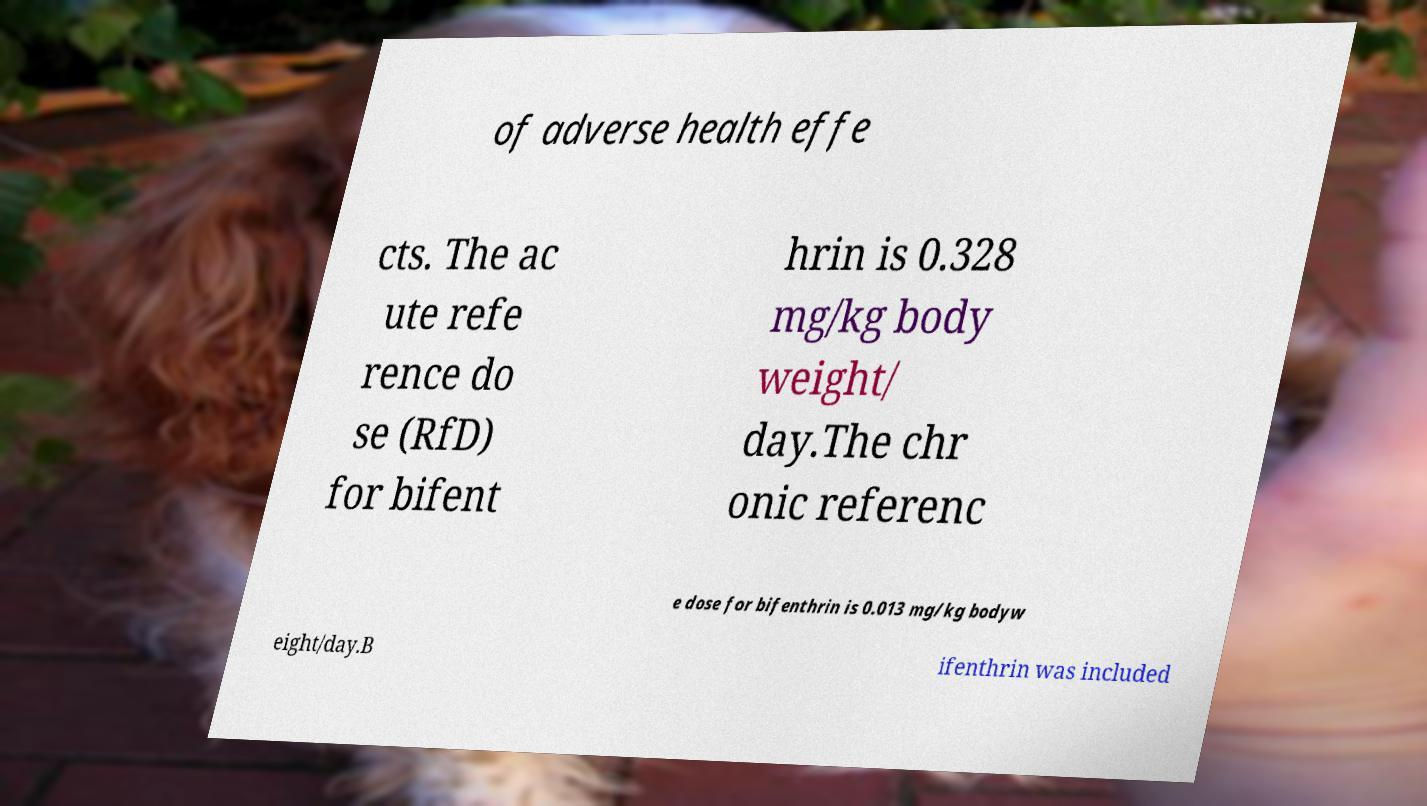There's text embedded in this image that I need extracted. Can you transcribe it verbatim? of adverse health effe cts. The ac ute refe rence do se (RfD) for bifent hrin is 0.328 mg/kg body weight/ day.The chr onic referenc e dose for bifenthrin is 0.013 mg/kg bodyw eight/day.B ifenthrin was included 